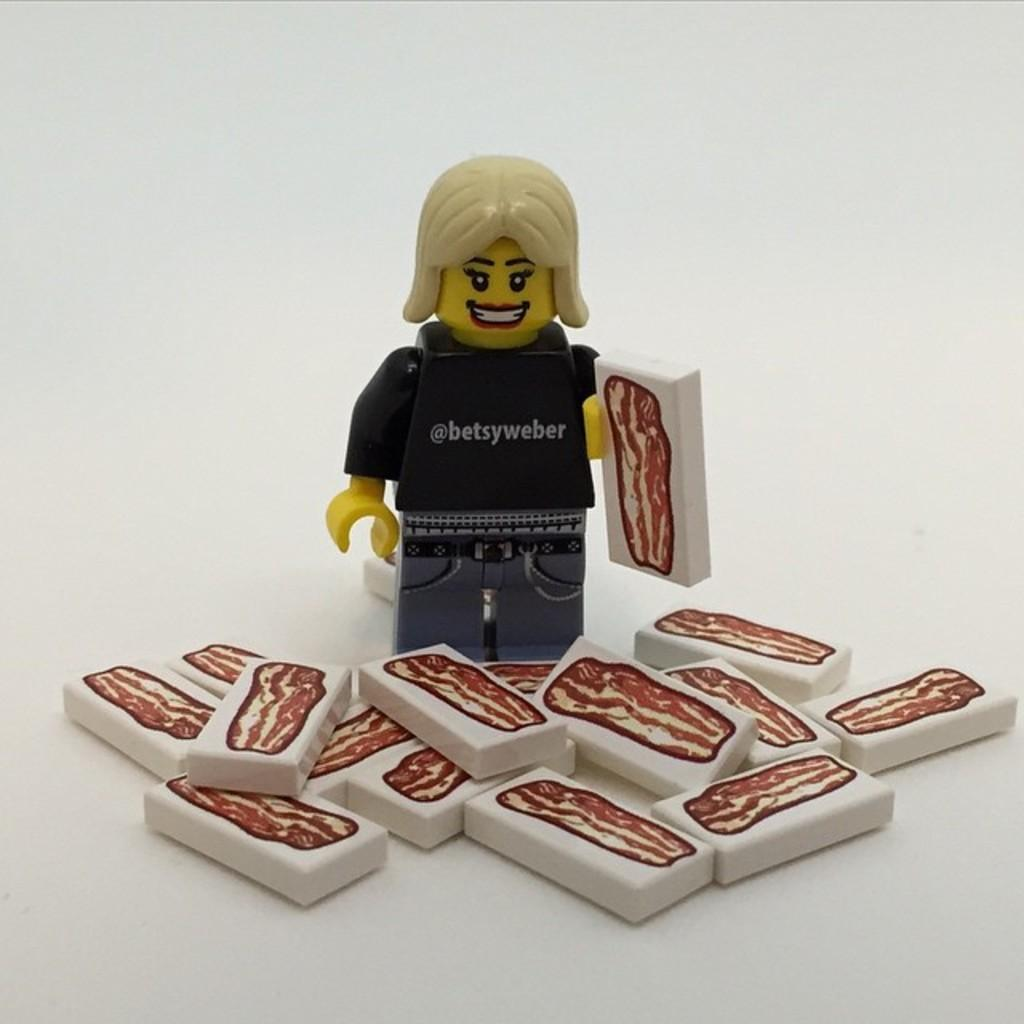What is the main subject in the image? There is a statue in the image. What else can be seen in the image besides the statue? There are small objects in the image. What is the statue learning in the image? The statue is not learning anything in the image, as it is an inanimate object. 